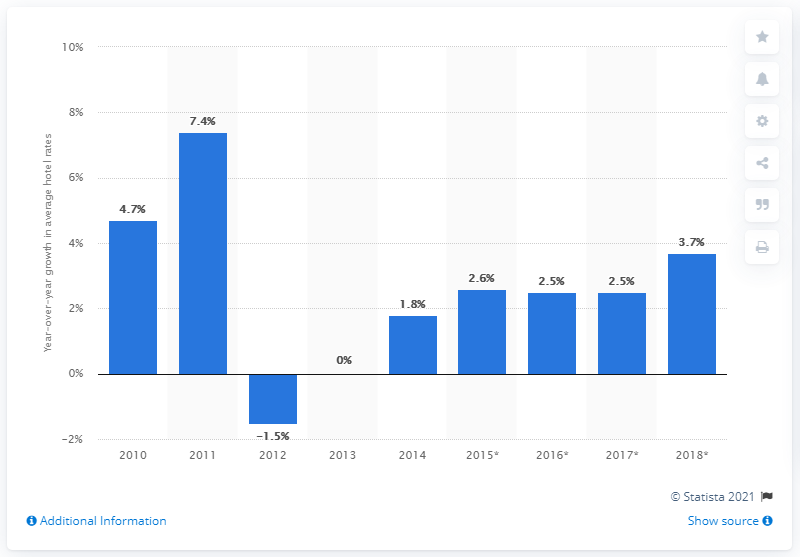Indicate a few pertinent items in this graphic. According to the forecast, global hotel rates were expected to increase by 3.7% in 2018. 